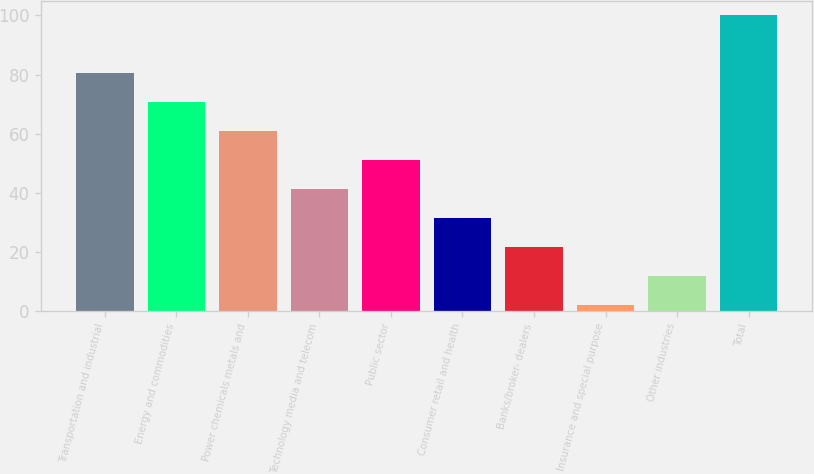Convert chart to OTSL. <chart><loc_0><loc_0><loc_500><loc_500><bar_chart><fcel>Transportation and industrial<fcel>Energy and commodities<fcel>Power chemicals metals and<fcel>Technology media and telecom<fcel>Public sector<fcel>Consumer retail and health<fcel>Banks/broker- dealers<fcel>Insurance and special purpose<fcel>Other industries<fcel>Total<nl><fcel>80.4<fcel>70.6<fcel>60.8<fcel>41.2<fcel>51<fcel>31.4<fcel>21.6<fcel>2<fcel>11.8<fcel>100<nl></chart> 